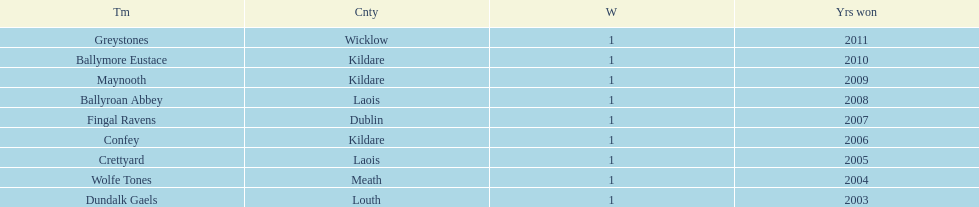Would you mind parsing the complete table? {'header': ['Tm', 'Cnty', 'W', 'Yrs won'], 'rows': [['Greystones', 'Wicklow', '1', '2011'], ['Ballymore Eustace', 'Kildare', '1', '2010'], ['Maynooth', 'Kildare', '1', '2009'], ['Ballyroan Abbey', 'Laois', '1', '2008'], ['Fingal Ravens', 'Dublin', '1', '2007'], ['Confey', 'Kildare', '1', '2006'], ['Crettyard', 'Laois', '1', '2005'], ['Wolfe Tones', 'Meath', '1', '2004'], ['Dundalk Gaels', 'Louth', '1', '2003']]} Which is the first team from the chart Greystones. 